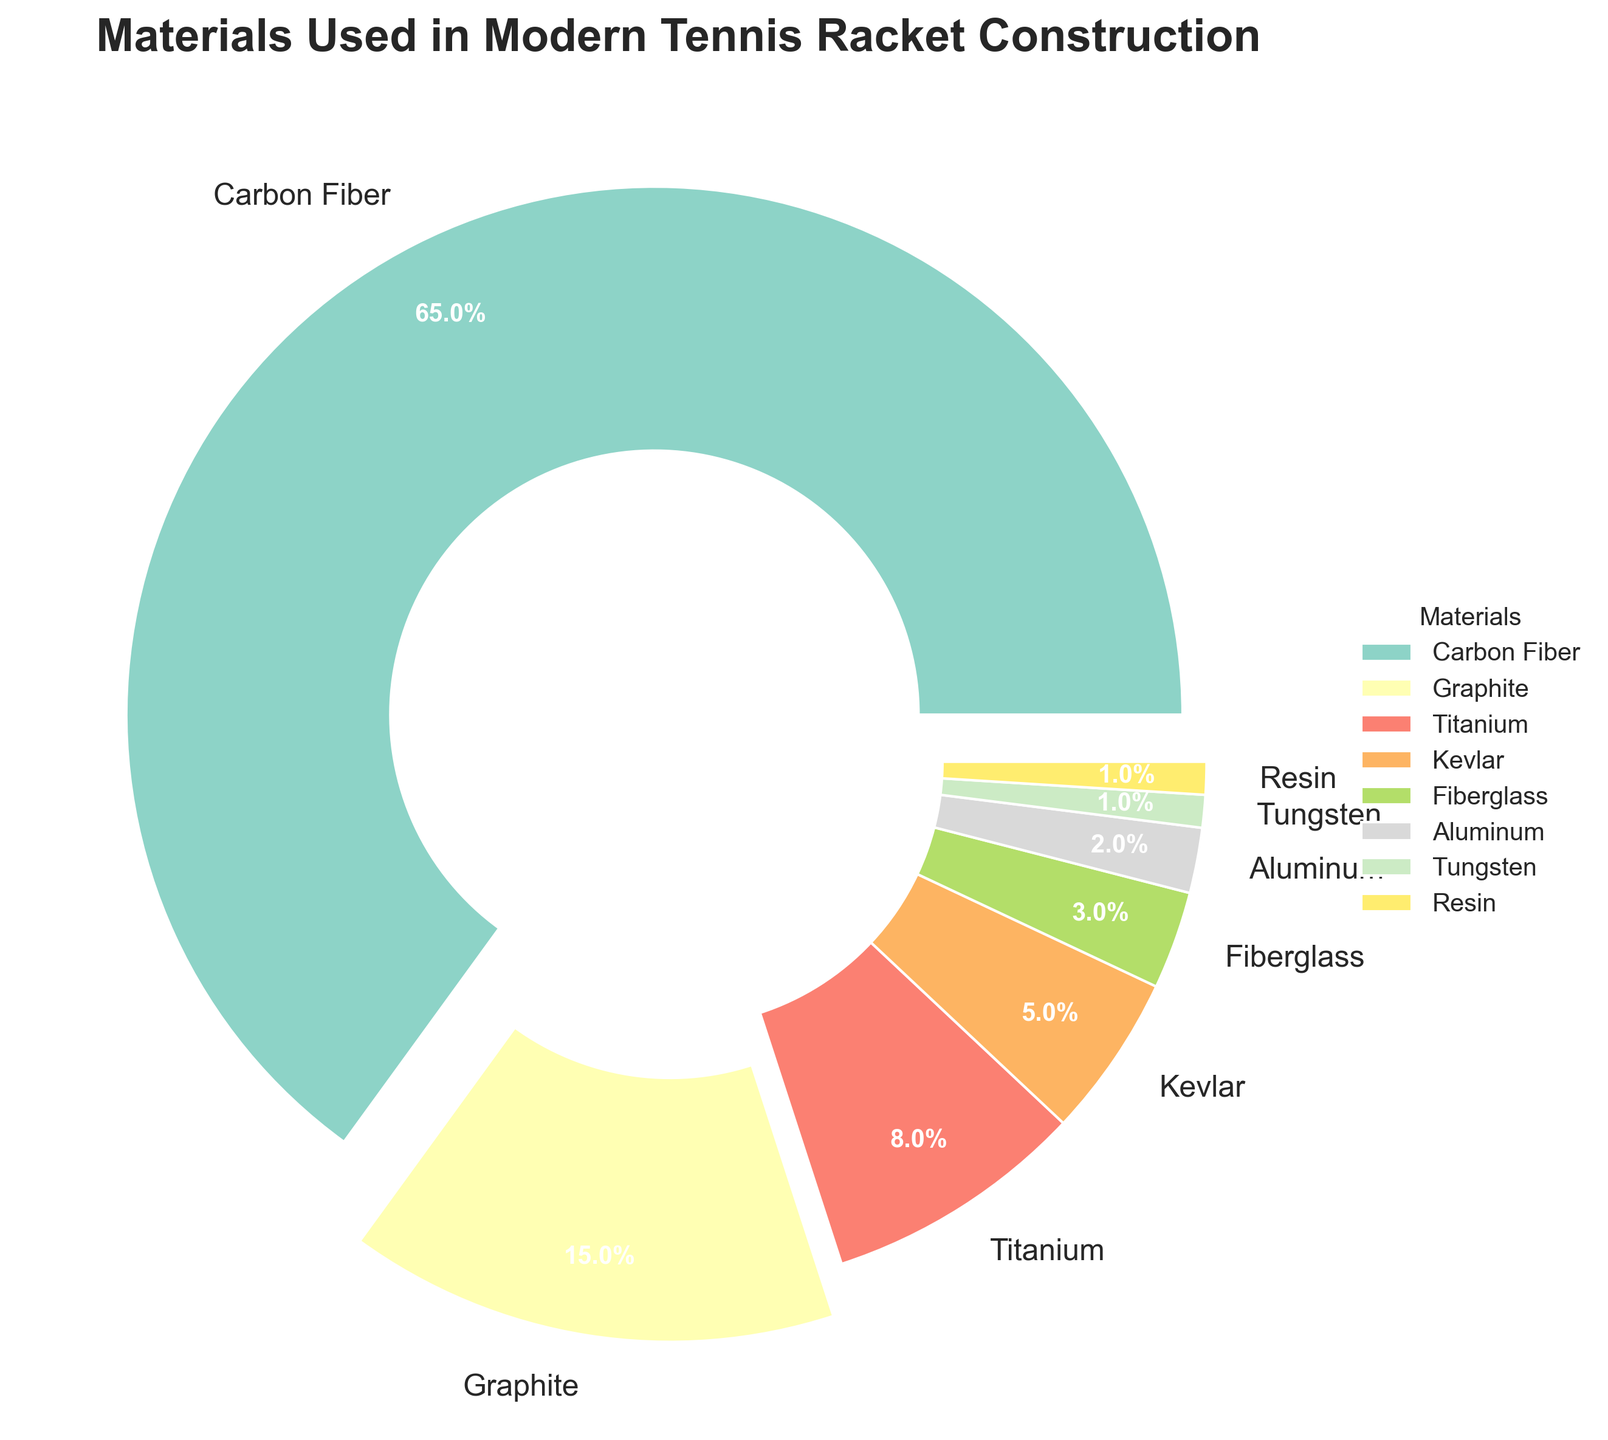How many materials in the pie chart have a percentage less than 5%? By examining the pie chart, we can see that Kevlar, Fiberglass, Aluminum, Tungsten, and Resin each have percentages of less than 5%. Counting these materials, we get: Kevlar (5%), Fiberglass (3%), Aluminum (2%), Tungsten (1%), and Resin (1%). That's 5 materials.
Answer: 5 Which material occupies the largest portion of the pie chart and what is its percentage? The largest portion of the pie chart is visually represented by the biggest wedge, which is Carbon Fiber. The pie chart shows Carbon Fiber at a percentage of 65%.
Answer: Carbon Fiber, 65% What is the combined percentage of Graphite and Kevlar? From the pie chart, Graphite has a percentage of 15% and Kevlar has a percentage of 5%. Adding these together, we get 15% + 5% = 20%.
Answer: 20% Which material contributes 8% to the pie chart? By referring to the pie chart, we can see that Titanium is listed with a percentage of 8%.
Answer: Titanium Is the percentage of Aluminum greater than that of Tungsten? From the pie chart, Aluminum has a percentage of 2% and Tungsten has a percentage of 1%. Comparing these two values, it is clear that 2% (Aluminum) is greater than 1% (Tungsten).
Answer: Yes What are the three least-used materials in the pie chart and their combined percentage? To find the three least-used materials, we look at the smallest slices of the pie chart. These are Tungsten (1%), Resin (1%), and Aluminum (2%). Adding these, we get: 1% + 1% + 2% = 4%.
Answer: Tungsten, Resin, Aluminum, 4% Does Graphite have a higher percentage than Titanium and Kevlar combined? First, we find the combined percentage of Titanium and Kevlar: 8% (Titanium) + 5% (Kevlar) = 13%. Next, we compare this to Graphite's percentage of 15%. Since 15% is greater than 13%, Graphite does have a higher percentage than the combined total of Titanium and Kevlar.
Answer: Yes What is the difference in percentage between Carbon Fiber and all other materials combined? First, note that Carbon Fiber has 65%. Summing the percentages of all other materials: 15% (Graphite) + 8% (Titanium) + 5% (Kevlar) + 3% (Fiberglass) + 2% (Aluminum) + 1% (Tungsten) + 1% (Resin) = 35%. The difference is 65% (Carbon Fiber) - 35% (others) = 30%.
Answer: 30% How many materials have a percentage equal to or more than 10%? Examining the pie chart, we see that the materials with percentages equal to or more than 10% are Carbon Fiber (65%) and Graphite (15%). That's a total of 2 materials.
Answer: 2 